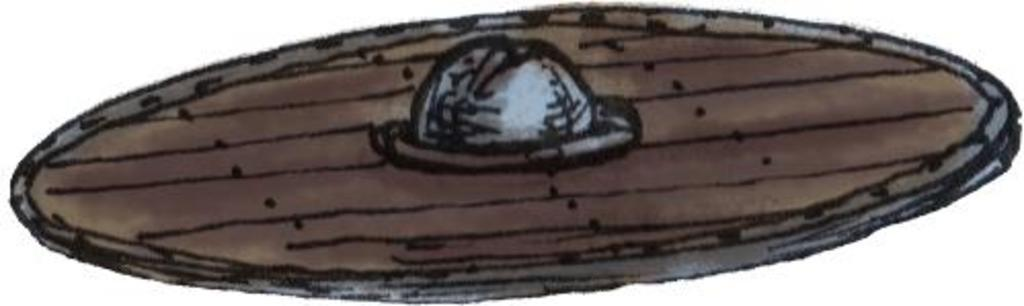What is featured in the image? There is a poster in the image. What is the subject matter of the poster? The poster depicts art. Can you see any sea creatures depicted on the poster? There is no mention of sea creatures or any marine life in the provided facts, so we cannot determine if they are present on the poster. 